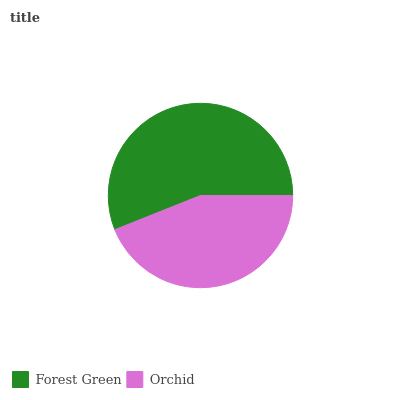Is Orchid the minimum?
Answer yes or no. Yes. Is Forest Green the maximum?
Answer yes or no. Yes. Is Orchid the maximum?
Answer yes or no. No. Is Forest Green greater than Orchid?
Answer yes or no. Yes. Is Orchid less than Forest Green?
Answer yes or no. Yes. Is Orchid greater than Forest Green?
Answer yes or no. No. Is Forest Green less than Orchid?
Answer yes or no. No. Is Forest Green the high median?
Answer yes or no. Yes. Is Orchid the low median?
Answer yes or no. Yes. Is Orchid the high median?
Answer yes or no. No. Is Forest Green the low median?
Answer yes or no. No. 